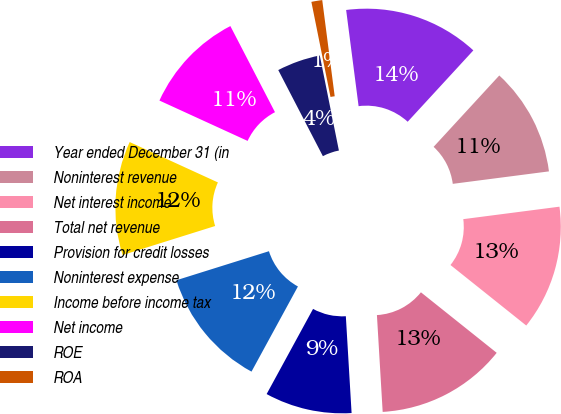<chart> <loc_0><loc_0><loc_500><loc_500><pie_chart><fcel>Year ended December 31 (in<fcel>Noninterest revenue<fcel>Net interest income<fcel>Total net revenue<fcel>Provision for credit losses<fcel>Noninterest expense<fcel>Income before income tax<fcel>Net income<fcel>ROE<fcel>ROA<nl><fcel>13.89%<fcel>11.11%<fcel>12.78%<fcel>13.33%<fcel>8.89%<fcel>12.22%<fcel>11.67%<fcel>10.56%<fcel>4.45%<fcel>1.11%<nl></chart> 